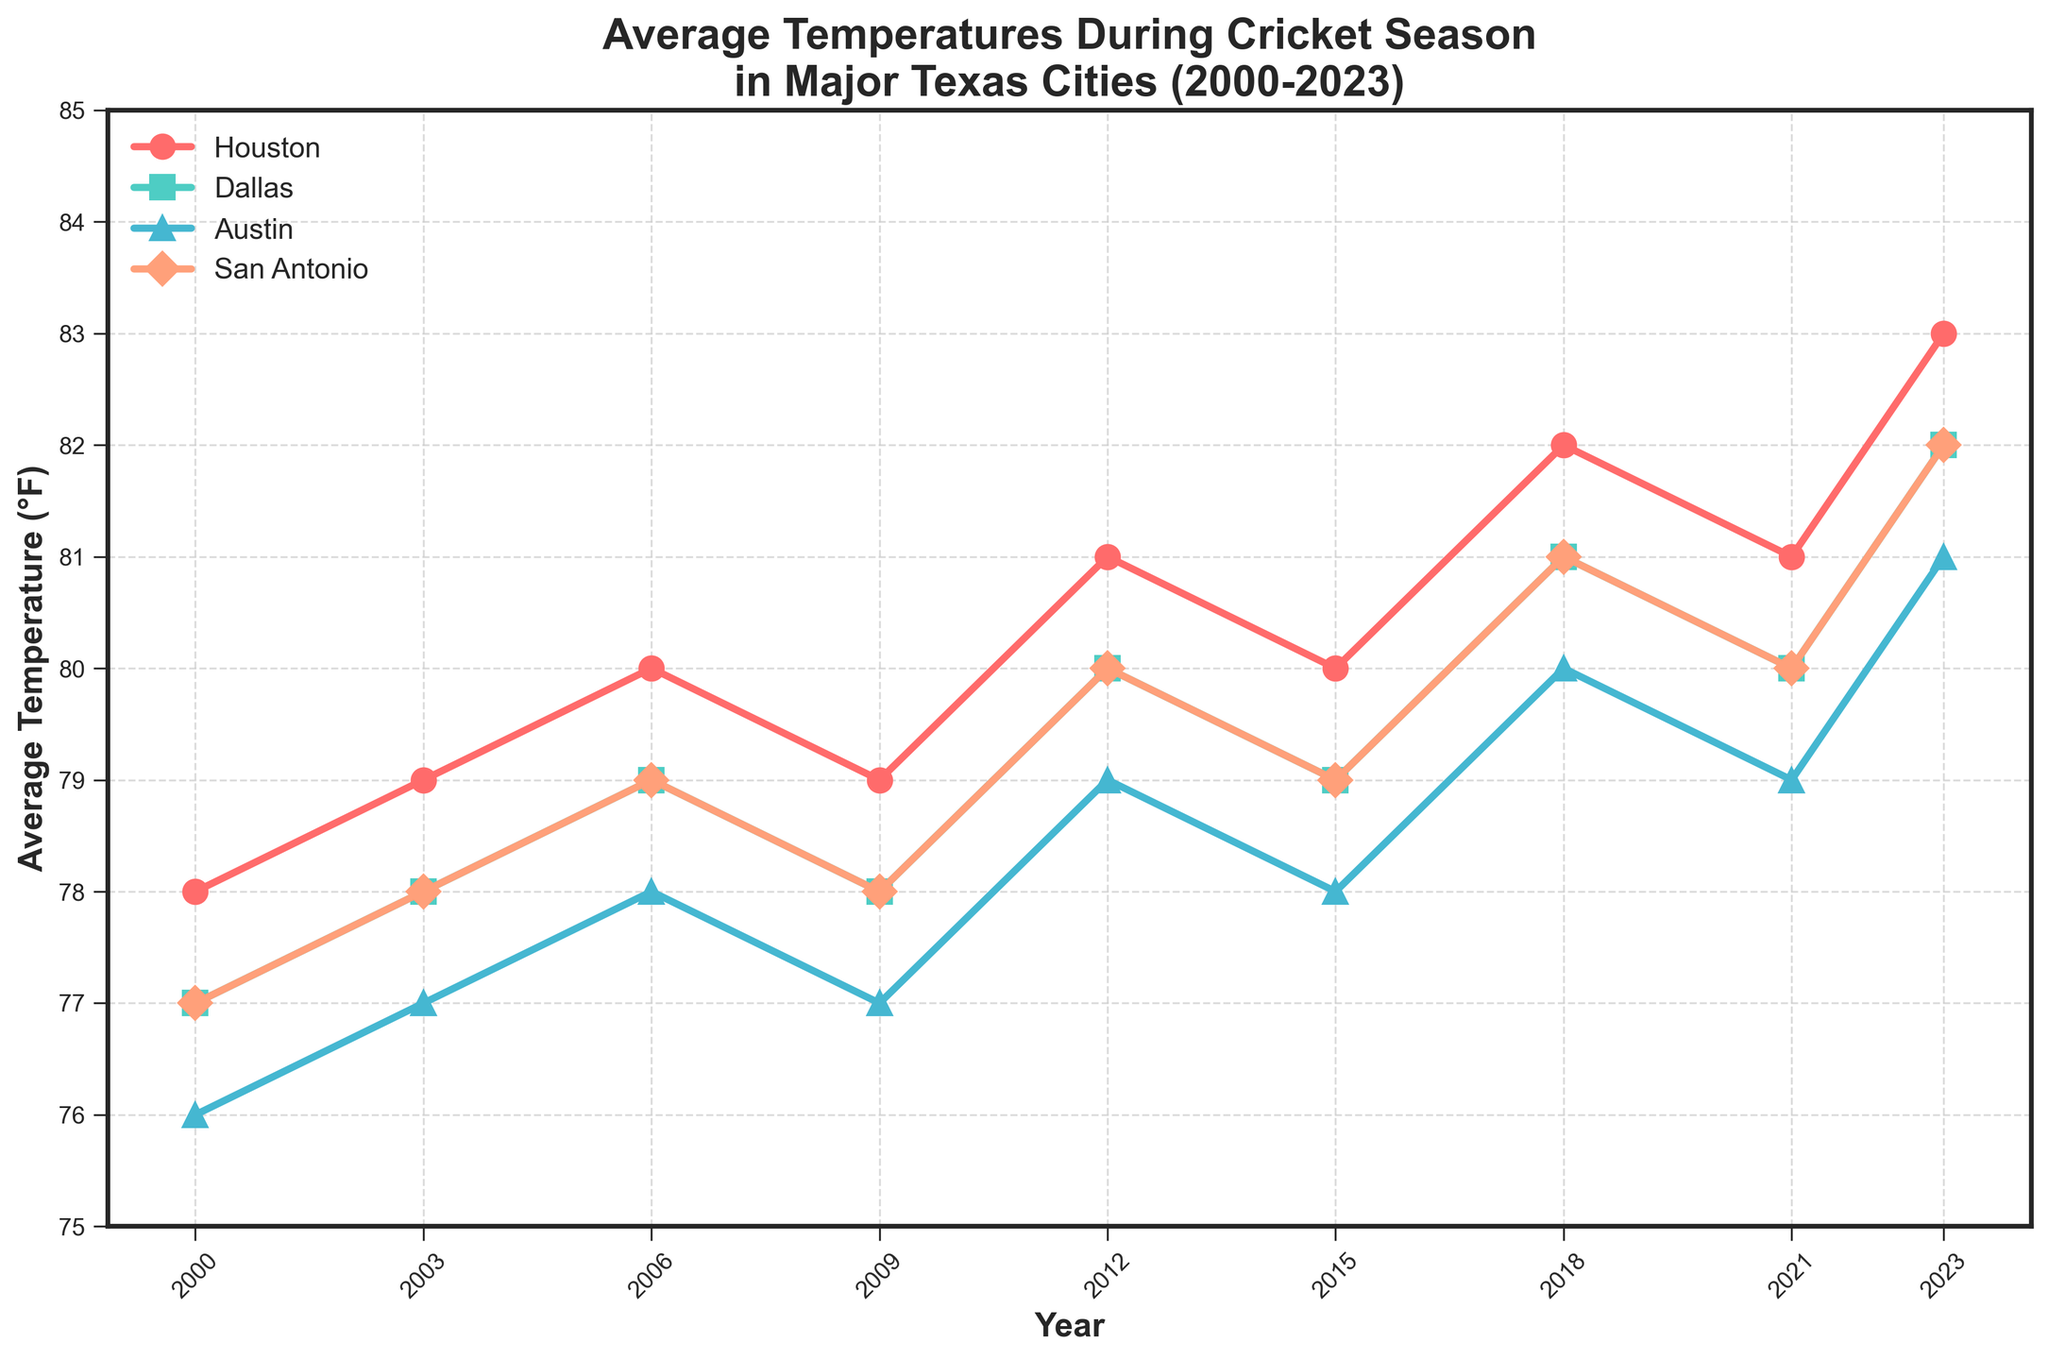Which city has the highest average temperature in 2023? In 2023, Houston has an average temperature of 83°F, Dallas has 82°F, Austin has 81°F, and San Antonio has 82°F. The highest value is for Houston.
Answer: Houston Between 2006 and 2021, which city's temperature showed the least fluctuation? By observing the changes in the temperatures over the years for each city, we see that Austin's temperature changes the least, fluctuating only between 77°F and 80°F from 2006 to 2021.
Answer: Austin What's the overall trend in average temperatures during cricket season across all four cities from 2000 to 2023? The overall trend indicates a steady increase in average temperatures in all four cities from 2000 to 2023.
Answer: Increasing In which year did Dallas and Austin have the same average temperature, and what was it? By comparing the temperatures for both Dallas and Austin, in 2009, they both have an average temperature of 77°F.
Answer: 2009, 77°F Which city showed the biggest increase in average temperature from 2015 to 2023? To find this, calculate the temperature difference for each city: Houston (83-80=3), Dallas (82-79=3), Austin (81-78=3), San Antonio (82-79=3). All cities show an increase of 3°F, which is equally the largest.
Answer: All cities Between which consecutive years did San Antonio experience the largest rise in average temperature? By comparing consecutive years, the largest rise for San Antonio can be observed from 2018 to 2023, where the temperature increases from 81°F to 82°F.
Answer: 2018 to 2023 Which color line represents Austin, and what are the markers used? By looking at the figure, Austin is represented by a blue line with triangle (^) markers.
Answer: Blue, Triangle In which year did Houston surpass a temperature of 80°F, and has it ever gone below this after surpassing it? Houston’s average temperature surpassed 80°F in 2012 (81°F) and has never gone below 80°F after 2012.
Answer: 2012, No 